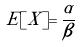<formula> <loc_0><loc_0><loc_500><loc_500>E [ X ] = \frac { \alpha } { \beta }</formula> 